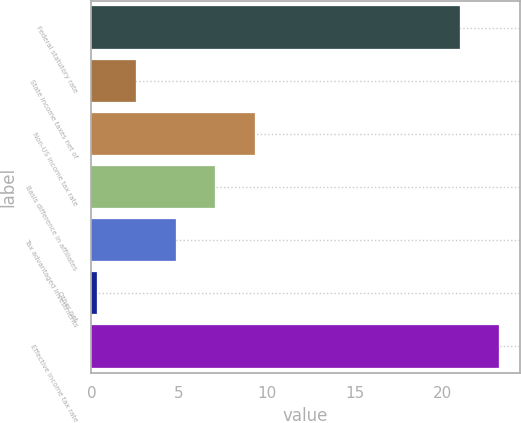Convert chart to OTSL. <chart><loc_0><loc_0><loc_500><loc_500><bar_chart><fcel>Federal statutory rate<fcel>State income taxes net of<fcel>Non-US income tax rate<fcel>Basis difference in affiliates<fcel>Tax advantaged investments<fcel>Other net<fcel>Effective income tax rate<nl><fcel>21<fcel>2.55<fcel>9.3<fcel>7.05<fcel>4.8<fcel>0.3<fcel>23.25<nl></chart> 